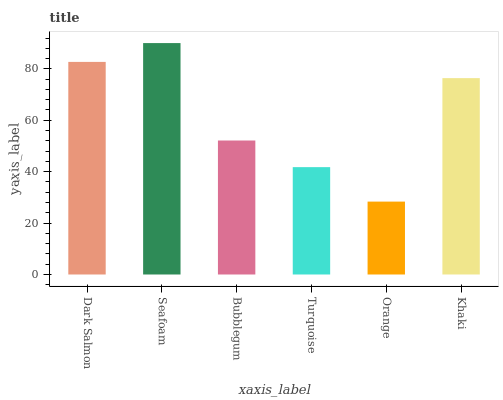Is Orange the minimum?
Answer yes or no. Yes. Is Seafoam the maximum?
Answer yes or no. Yes. Is Bubblegum the minimum?
Answer yes or no. No. Is Bubblegum the maximum?
Answer yes or no. No. Is Seafoam greater than Bubblegum?
Answer yes or no. Yes. Is Bubblegum less than Seafoam?
Answer yes or no. Yes. Is Bubblegum greater than Seafoam?
Answer yes or no. No. Is Seafoam less than Bubblegum?
Answer yes or no. No. Is Khaki the high median?
Answer yes or no. Yes. Is Bubblegum the low median?
Answer yes or no. Yes. Is Turquoise the high median?
Answer yes or no. No. Is Turquoise the low median?
Answer yes or no. No. 